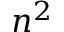<formula> <loc_0><loc_0><loc_500><loc_500>n ^ { 2 }</formula> 